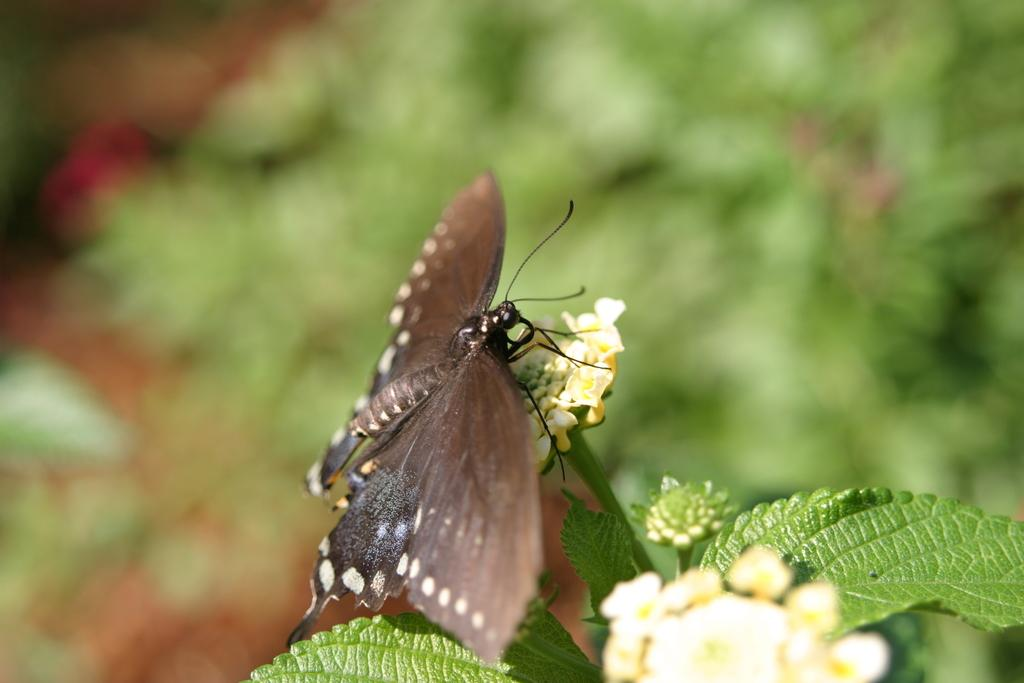What is the main subject of the image? There is a butterfly in the image. Where is the butterfly located? The butterfly is on a plant. What is the position of the butterfly and plant in the image? The butterfly and plant are in the center of the image. What type of space design can be seen in the background of the image? There is no reference to a space design or background in the image, as it features a butterfly on a plant. 